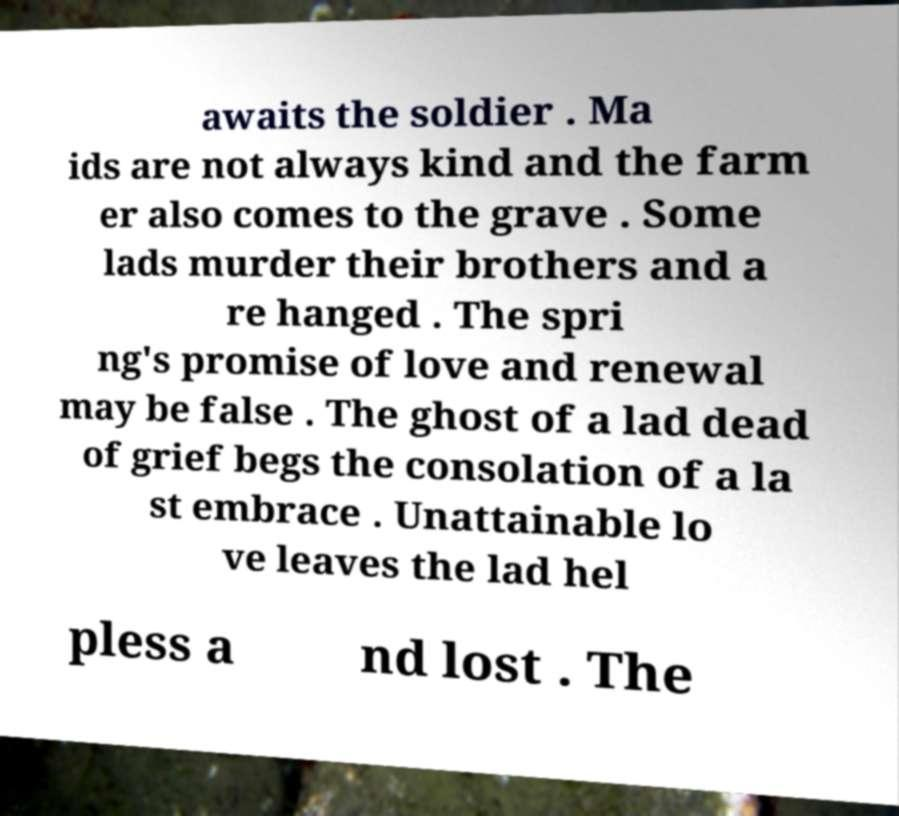Please identify and transcribe the text found in this image. awaits the soldier . Ma ids are not always kind and the farm er also comes to the grave . Some lads murder their brothers and a re hanged . The spri ng's promise of love and renewal may be false . The ghost of a lad dead of grief begs the consolation of a la st embrace . Unattainable lo ve leaves the lad hel pless a nd lost . The 